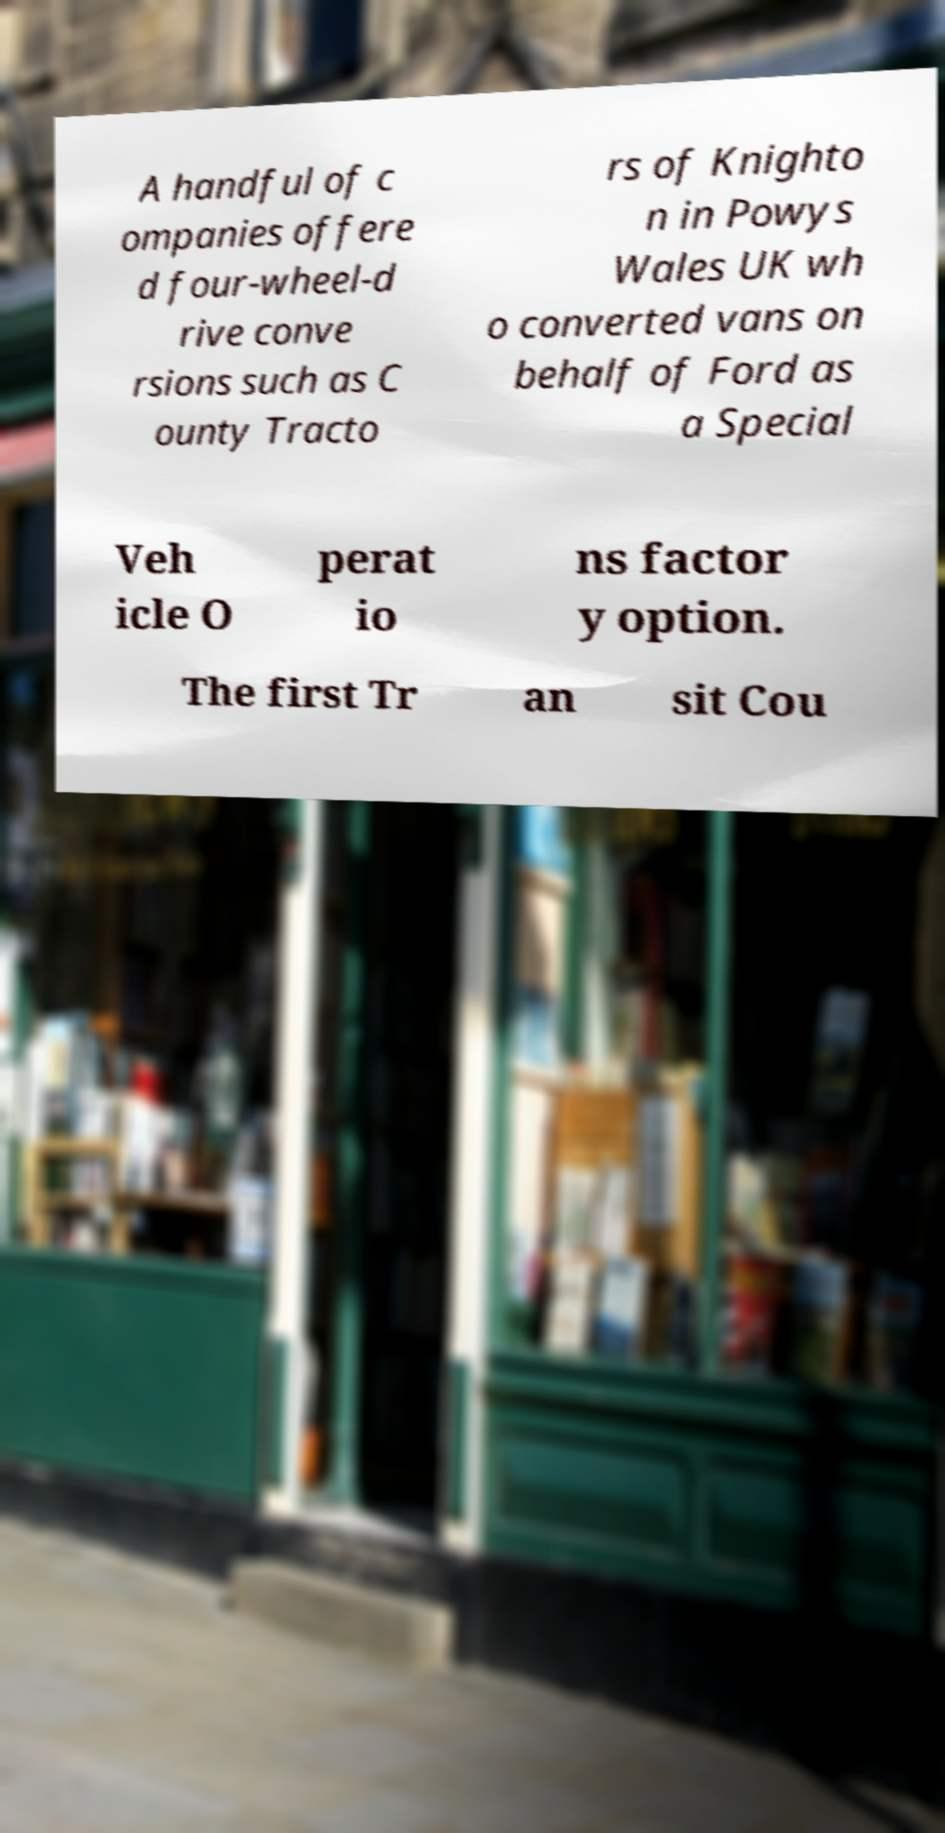Please identify and transcribe the text found in this image. A handful of c ompanies offere d four-wheel-d rive conve rsions such as C ounty Tracto rs of Knighto n in Powys Wales UK wh o converted vans on behalf of Ford as a Special Veh icle O perat io ns factor y option. The first Tr an sit Cou 